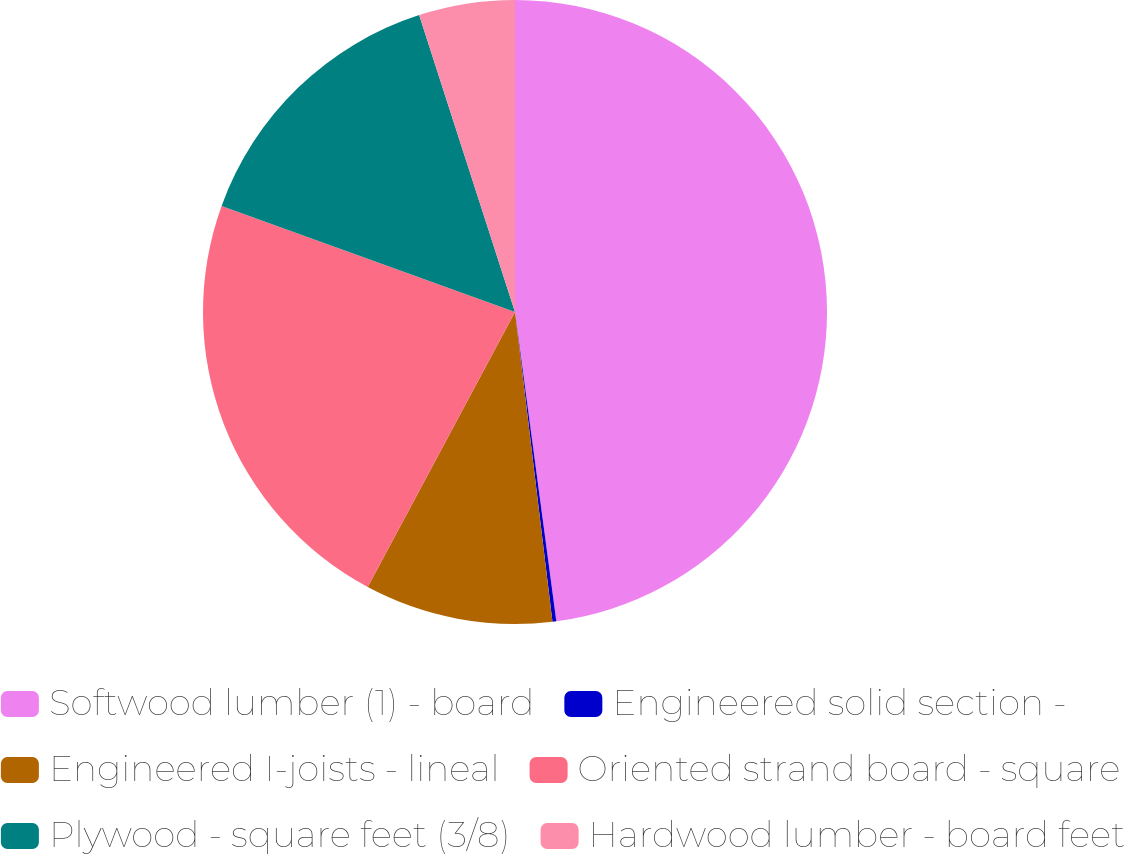<chart> <loc_0><loc_0><loc_500><loc_500><pie_chart><fcel>Softwood lumber (1) - board<fcel>Engineered solid section -<fcel>Engineered I-joists - lineal<fcel>Oriented strand board - square<fcel>Plywood - square feet (3/8)<fcel>Hardwood lumber - board feet<nl><fcel>47.89%<fcel>0.2%<fcel>9.74%<fcel>22.7%<fcel>14.51%<fcel>4.97%<nl></chart> 